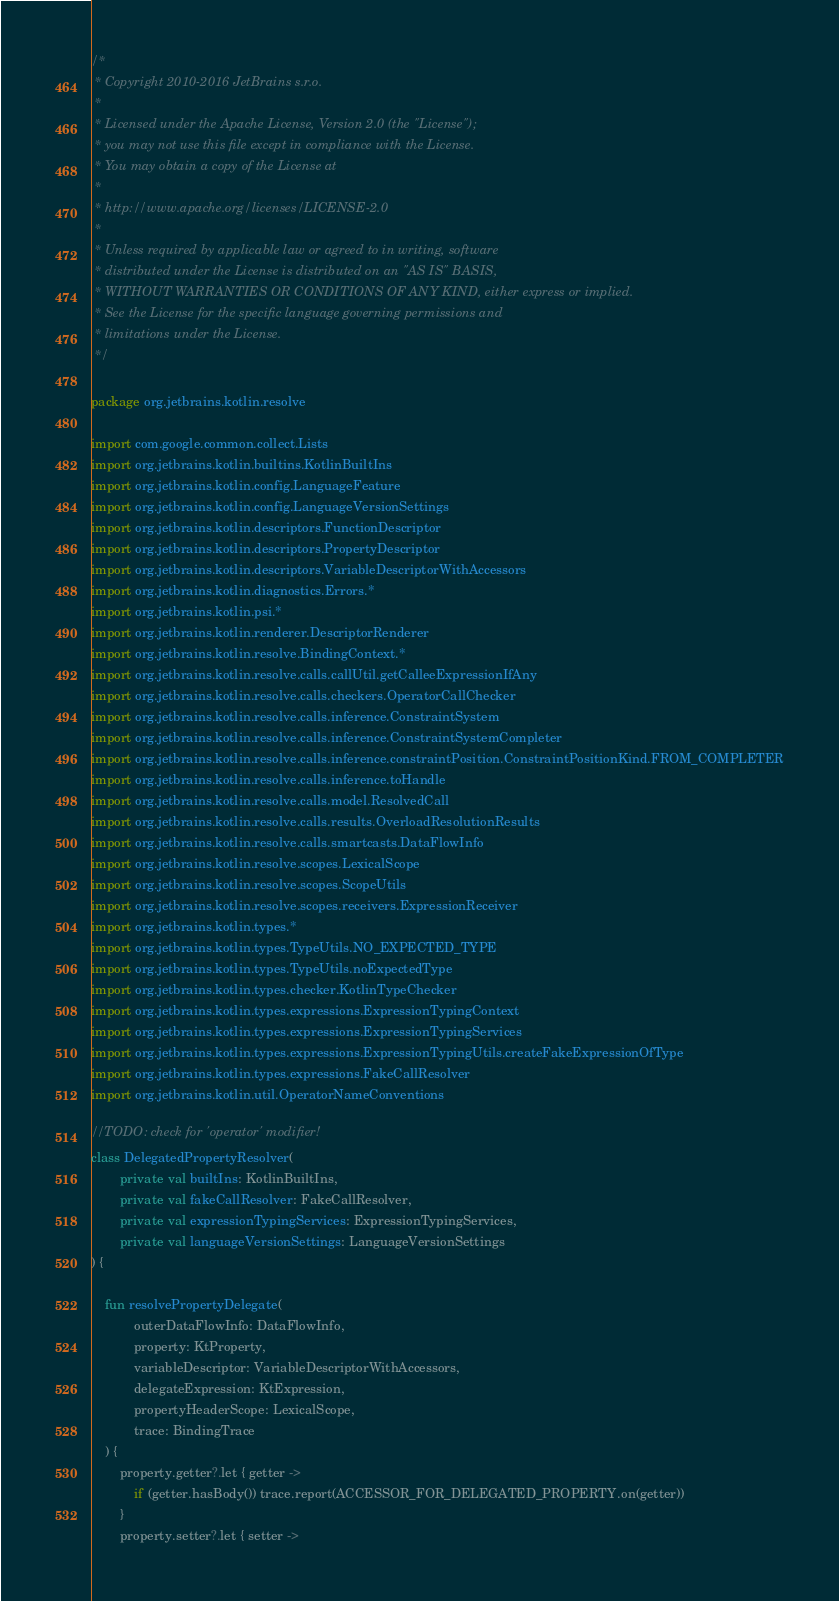Convert code to text. <code><loc_0><loc_0><loc_500><loc_500><_Kotlin_>/*
 * Copyright 2010-2016 JetBrains s.r.o.
 *
 * Licensed under the Apache License, Version 2.0 (the "License");
 * you may not use this file except in compliance with the License.
 * You may obtain a copy of the License at
 *
 * http://www.apache.org/licenses/LICENSE-2.0
 *
 * Unless required by applicable law or agreed to in writing, software
 * distributed under the License is distributed on an "AS IS" BASIS,
 * WITHOUT WARRANTIES OR CONDITIONS OF ANY KIND, either express or implied.
 * See the License for the specific language governing permissions and
 * limitations under the License.
 */

package org.jetbrains.kotlin.resolve

import com.google.common.collect.Lists
import org.jetbrains.kotlin.builtins.KotlinBuiltIns
import org.jetbrains.kotlin.config.LanguageFeature
import org.jetbrains.kotlin.config.LanguageVersionSettings
import org.jetbrains.kotlin.descriptors.FunctionDescriptor
import org.jetbrains.kotlin.descriptors.PropertyDescriptor
import org.jetbrains.kotlin.descriptors.VariableDescriptorWithAccessors
import org.jetbrains.kotlin.diagnostics.Errors.*
import org.jetbrains.kotlin.psi.*
import org.jetbrains.kotlin.renderer.DescriptorRenderer
import org.jetbrains.kotlin.resolve.BindingContext.*
import org.jetbrains.kotlin.resolve.calls.callUtil.getCalleeExpressionIfAny
import org.jetbrains.kotlin.resolve.calls.checkers.OperatorCallChecker
import org.jetbrains.kotlin.resolve.calls.inference.ConstraintSystem
import org.jetbrains.kotlin.resolve.calls.inference.ConstraintSystemCompleter
import org.jetbrains.kotlin.resolve.calls.inference.constraintPosition.ConstraintPositionKind.FROM_COMPLETER
import org.jetbrains.kotlin.resolve.calls.inference.toHandle
import org.jetbrains.kotlin.resolve.calls.model.ResolvedCall
import org.jetbrains.kotlin.resolve.calls.results.OverloadResolutionResults
import org.jetbrains.kotlin.resolve.calls.smartcasts.DataFlowInfo
import org.jetbrains.kotlin.resolve.scopes.LexicalScope
import org.jetbrains.kotlin.resolve.scopes.ScopeUtils
import org.jetbrains.kotlin.resolve.scopes.receivers.ExpressionReceiver
import org.jetbrains.kotlin.types.*
import org.jetbrains.kotlin.types.TypeUtils.NO_EXPECTED_TYPE
import org.jetbrains.kotlin.types.TypeUtils.noExpectedType
import org.jetbrains.kotlin.types.checker.KotlinTypeChecker
import org.jetbrains.kotlin.types.expressions.ExpressionTypingContext
import org.jetbrains.kotlin.types.expressions.ExpressionTypingServices
import org.jetbrains.kotlin.types.expressions.ExpressionTypingUtils.createFakeExpressionOfType
import org.jetbrains.kotlin.types.expressions.FakeCallResolver
import org.jetbrains.kotlin.util.OperatorNameConventions

//TODO: check for 'operator' modifier!
class DelegatedPropertyResolver(
        private val builtIns: KotlinBuiltIns,
        private val fakeCallResolver: FakeCallResolver,
        private val expressionTypingServices: ExpressionTypingServices,
        private val languageVersionSettings: LanguageVersionSettings
) {

    fun resolvePropertyDelegate(
            outerDataFlowInfo: DataFlowInfo,
            property: KtProperty,
            variableDescriptor: VariableDescriptorWithAccessors,
            delegateExpression: KtExpression,
            propertyHeaderScope: LexicalScope,
            trace: BindingTrace
    ) {
        property.getter?.let { getter ->
            if (getter.hasBody()) trace.report(ACCESSOR_FOR_DELEGATED_PROPERTY.on(getter))
        }
        property.setter?.let { setter -></code> 